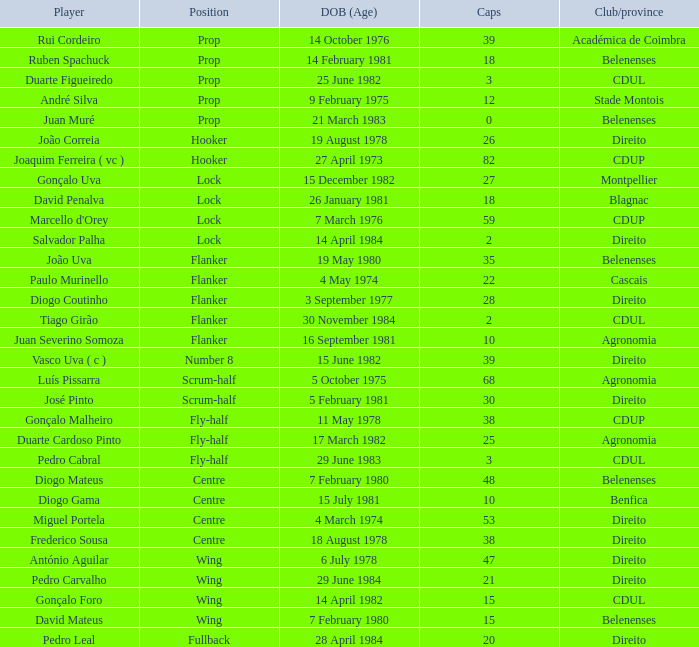Which competitor has a club/province of direito, less than 21 caps, and a position of lock? Salvador Palha. 